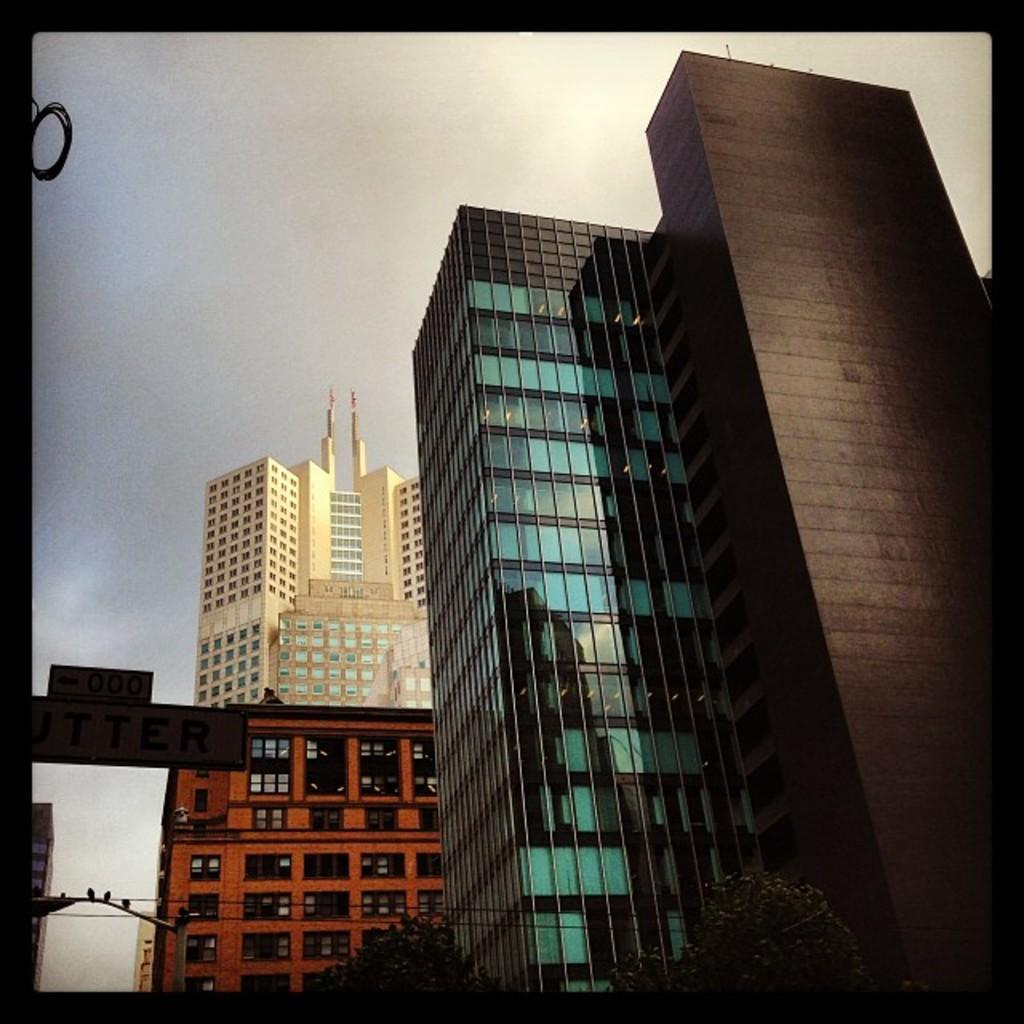What type of structures are present in the image? There are a group of buildings in the image. What type of vegetation can be seen at the bottom of the image? There are trees at the bottom of the image. What other objects can be seen in the image besides the buildings and trees? There are poles and wires in the image. What is visible at the top of the image? The sky is visible at the top of the image. Can you see any children playing with a hose near the trees in the image? There are no children or hoses present in the image. 